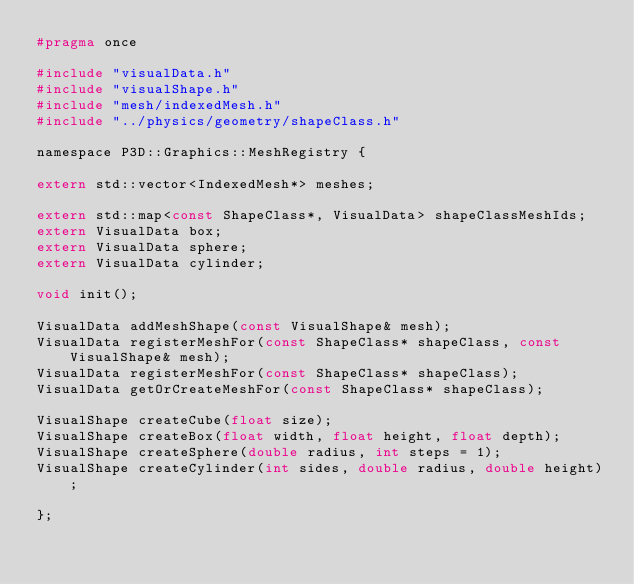Convert code to text. <code><loc_0><loc_0><loc_500><loc_500><_C_>#pragma once

#include "visualData.h"
#include "visualShape.h"
#include "mesh/indexedMesh.h"
#include "../physics/geometry/shapeClass.h"

namespace P3D::Graphics::MeshRegistry {

extern std::vector<IndexedMesh*> meshes;
	
extern std::map<const ShapeClass*, VisualData> shapeClassMeshIds;
extern VisualData box;
extern VisualData sphere;
extern VisualData cylinder;

void init();

VisualData addMeshShape(const VisualShape& mesh);
VisualData registerMeshFor(const ShapeClass* shapeClass, const VisualShape& mesh);
VisualData registerMeshFor(const ShapeClass* shapeClass);
VisualData getOrCreateMeshFor(const ShapeClass* shapeClass);

VisualShape createCube(float size);
VisualShape createBox(float width, float height, float depth);
VisualShape createSphere(double radius, int steps = 1);
VisualShape createCylinder(int sides, double radius, double height);

};
</code> 